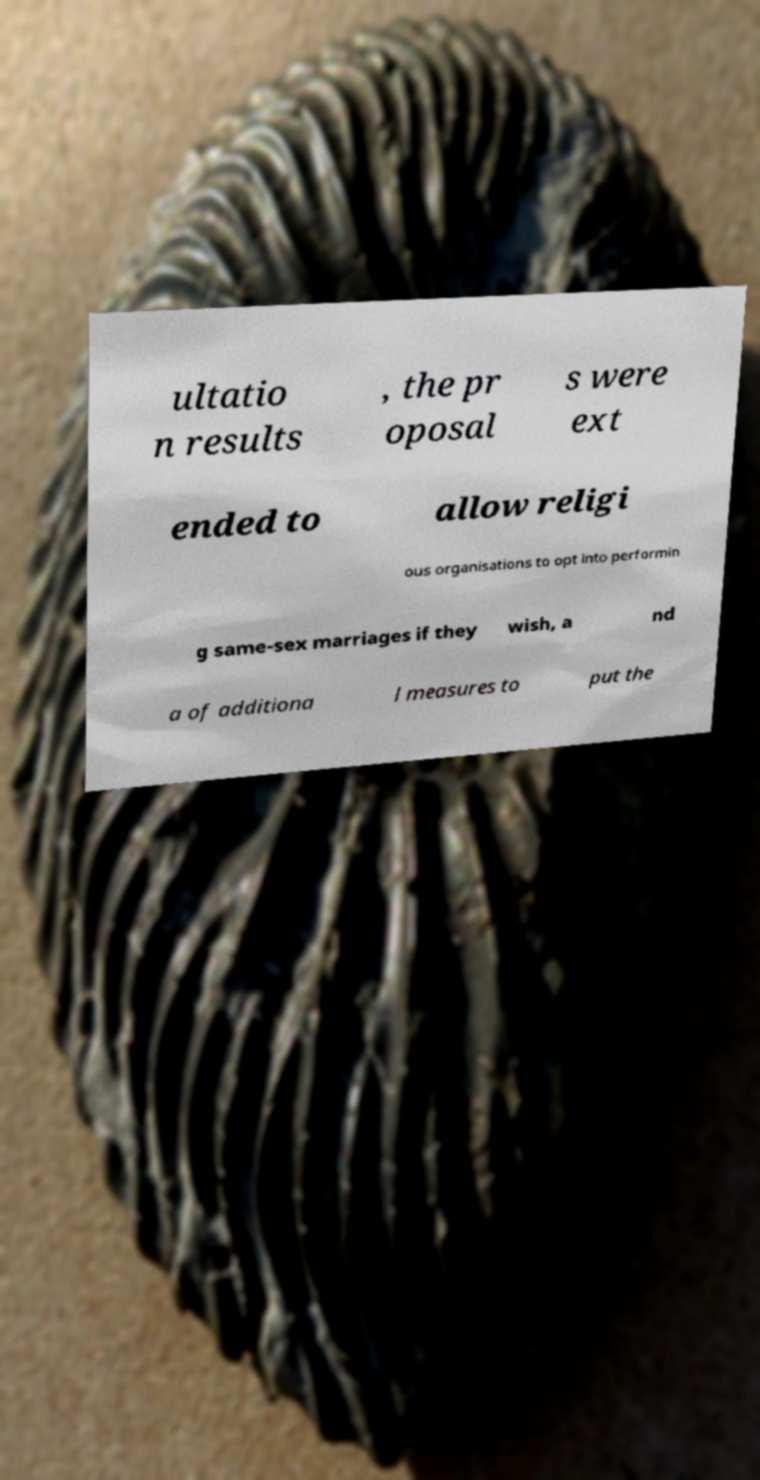For documentation purposes, I need the text within this image transcribed. Could you provide that? ultatio n results , the pr oposal s were ext ended to allow religi ous organisations to opt into performin g same-sex marriages if they wish, a nd a of additiona l measures to put the 